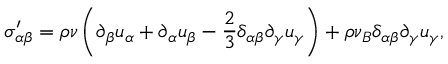Convert formula to latex. <formula><loc_0><loc_0><loc_500><loc_500>\sigma _ { \alpha \beta } ^ { \prime } = \rho \nu \left ( \partial _ { \beta } u _ { \alpha } + \partial _ { \alpha } u _ { \beta } - \frac { 2 } { 3 } \delta _ { \alpha \beta } \partial _ { \gamma } u _ { \gamma } \right ) + \rho \nu _ { B } \delta _ { \alpha \beta } \partial _ { \gamma } u _ { \gamma } ,</formula> 